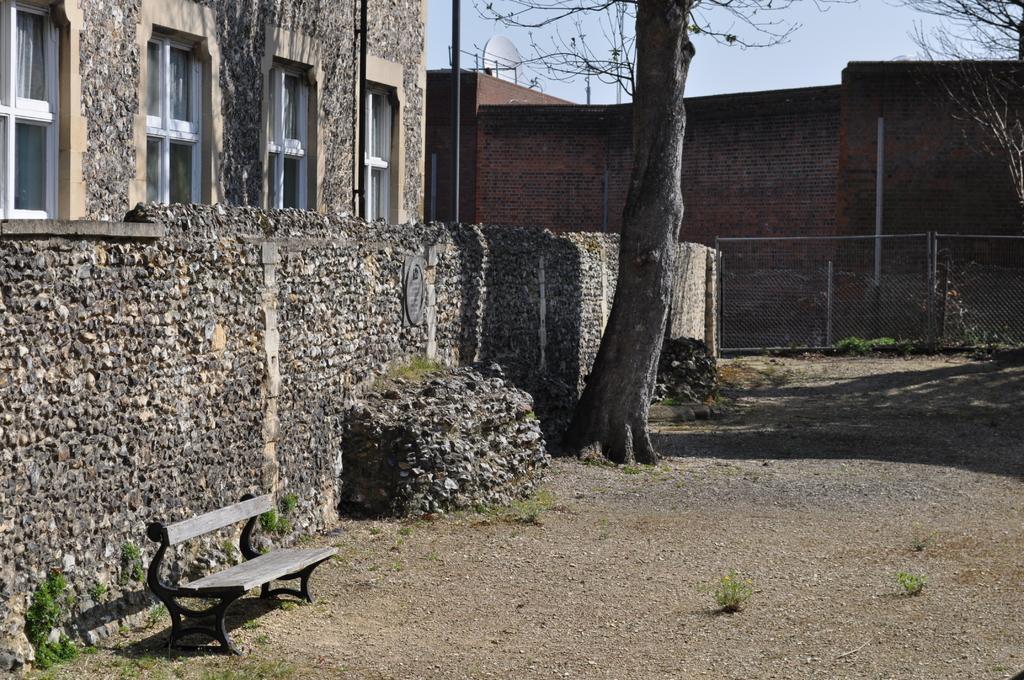Please provide a concise description of this image. In this image, there are buildings, poles, trees, fence and I can see an antenna on top of a building. In the bottom left side of the image, I can see a wooden bench on the ground. In the background, there is the sky. 